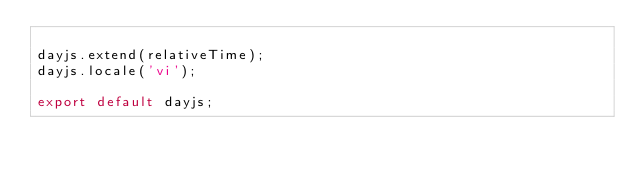<code> <loc_0><loc_0><loc_500><loc_500><_JavaScript_>
dayjs.extend(relativeTime);
dayjs.locale('vi');

export default dayjs;
</code> 